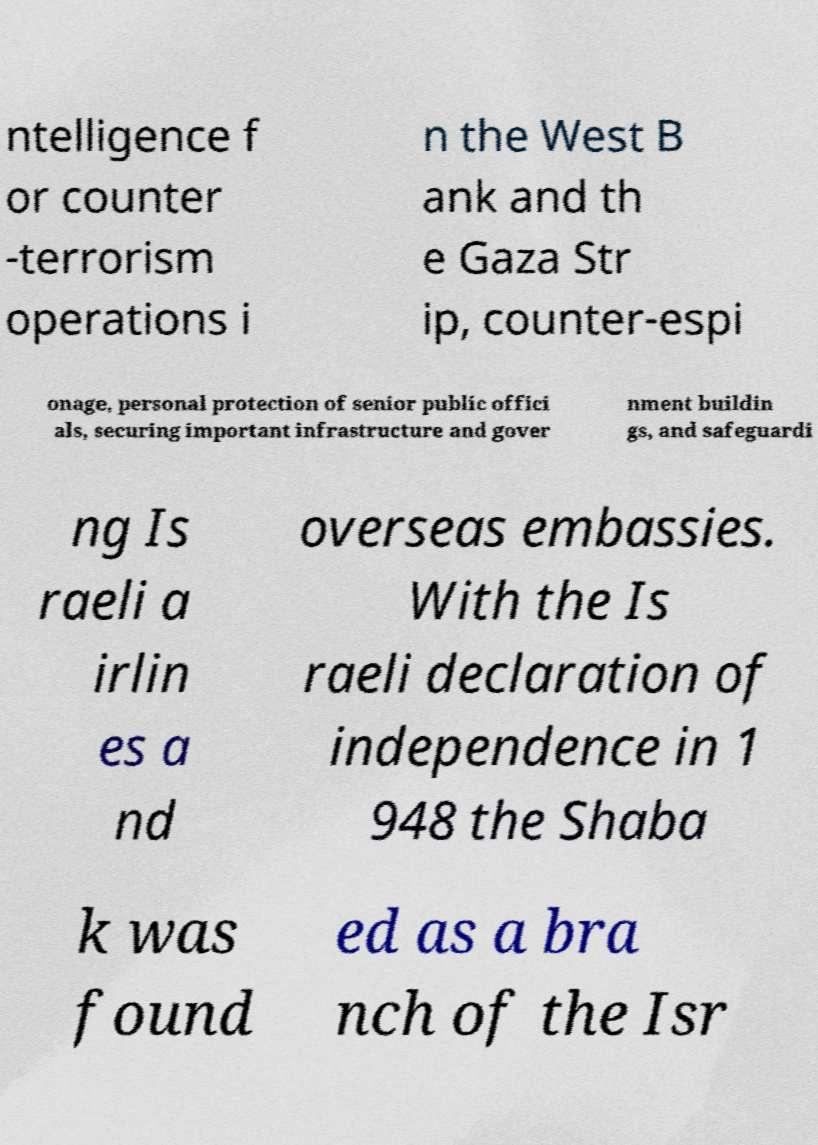For documentation purposes, I need the text within this image transcribed. Could you provide that? ntelligence f or counter -terrorism operations i n the West B ank and th e Gaza Str ip, counter-espi onage, personal protection of senior public offici als, securing important infrastructure and gover nment buildin gs, and safeguardi ng Is raeli a irlin es a nd overseas embassies. With the Is raeli declaration of independence in 1 948 the Shaba k was found ed as a bra nch of the Isr 